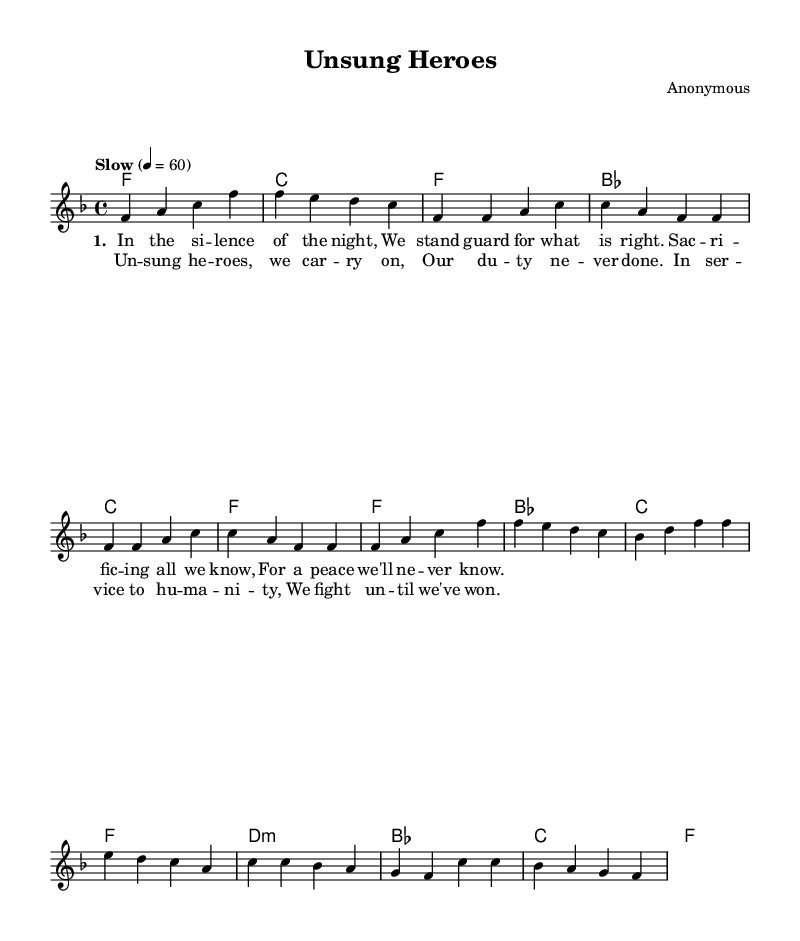What is the key signature of this music? The key signature is indicated at the beginning of the score with the key signature symbol. In this case, it shows one flat (B flat), which corresponds to the key of F major.
Answer: F major What is the time signature of this music? The time signature is found at the beginning of the score and is represented by two numbers stacked on top of each other. Here it reads 4 over 4, meaning there are four beats in a measure and the quarter note gets one beat.
Answer: 4/4 What tempo marking is indicated for this piece? The tempo marking is provided in words next to a number. In this score, it states "Slow" with a metronome marking of 60, meaning the piece should be played at a slow pace of 60 beats per minute.
Answer: Slow How many measures are there in the chorus section? To find the number of measures in the chorus, you look at the melody notes and the corresponding lyrics. The chorus contains four measures, represented by the respective harmonies and melody used in that part.
Answer: 4 What is the primary theme conveyed in the lyrics? The lyrics reflect themes of duty and service, emphasizing sacrifice for a larger cause, which is common in Soul music. By analyzing the lyrics in context, we can see they speak to fighting for humanity and honoring unsung heroes.
Answer: Duty and sacrifice What is the purpose of the bridge in a Soul ballad? The bridge serves to provide contrast to the verses and chorus, often highlighting emotional peaks or transitions. In this piece, it shifts the musical dynamics, which brings attention to the sacrifice theme before returning to the chorus.
Answer: Provide contrast What type of harmony is used in the bridge section? The harmony in the bridge uses a minor chord (d minor), which typically adds tension and a somber mood, characteristic of the reflective nature of Soul ballads. This is determined from analyzing the chord progression specific to the bridge.
Answer: Minor 